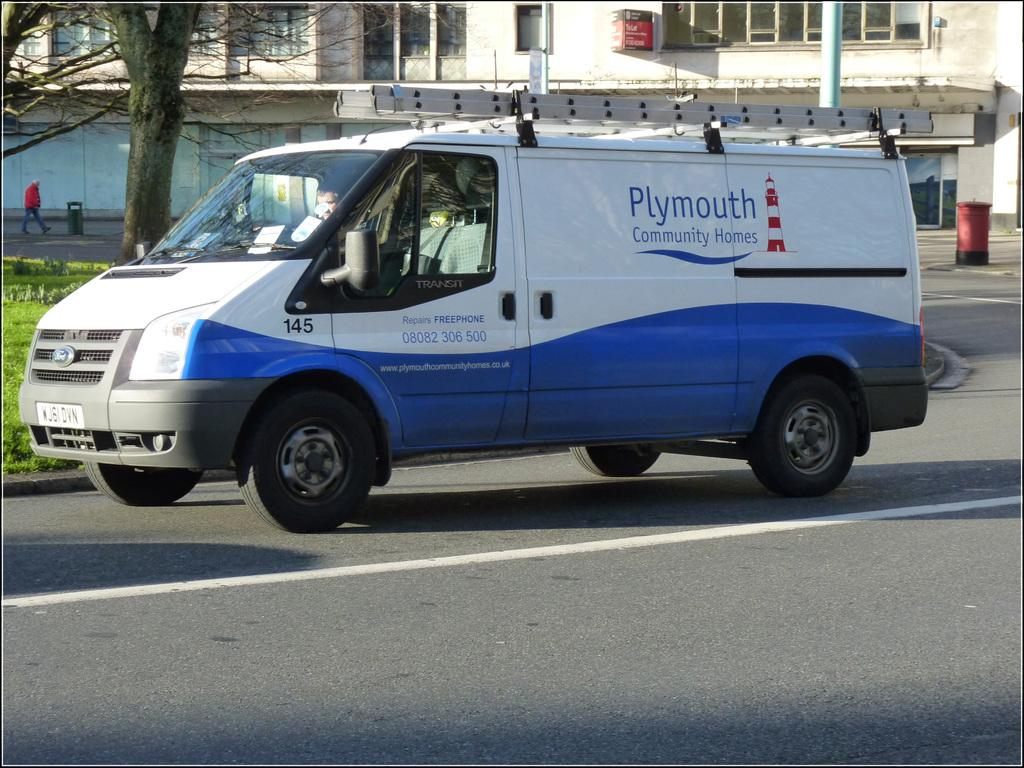What is on the road in the image? There is a vehicle on the road in the image. What type of vegetation can be seen in the image? There is grass visible in the image. What else can be seen in the image besides the grass? There are trees and a building in the image. What direction does the grass feel disgust towards in the image? The grass does not have feelings or emotions, so it cannot feel disgust towards any direction. 